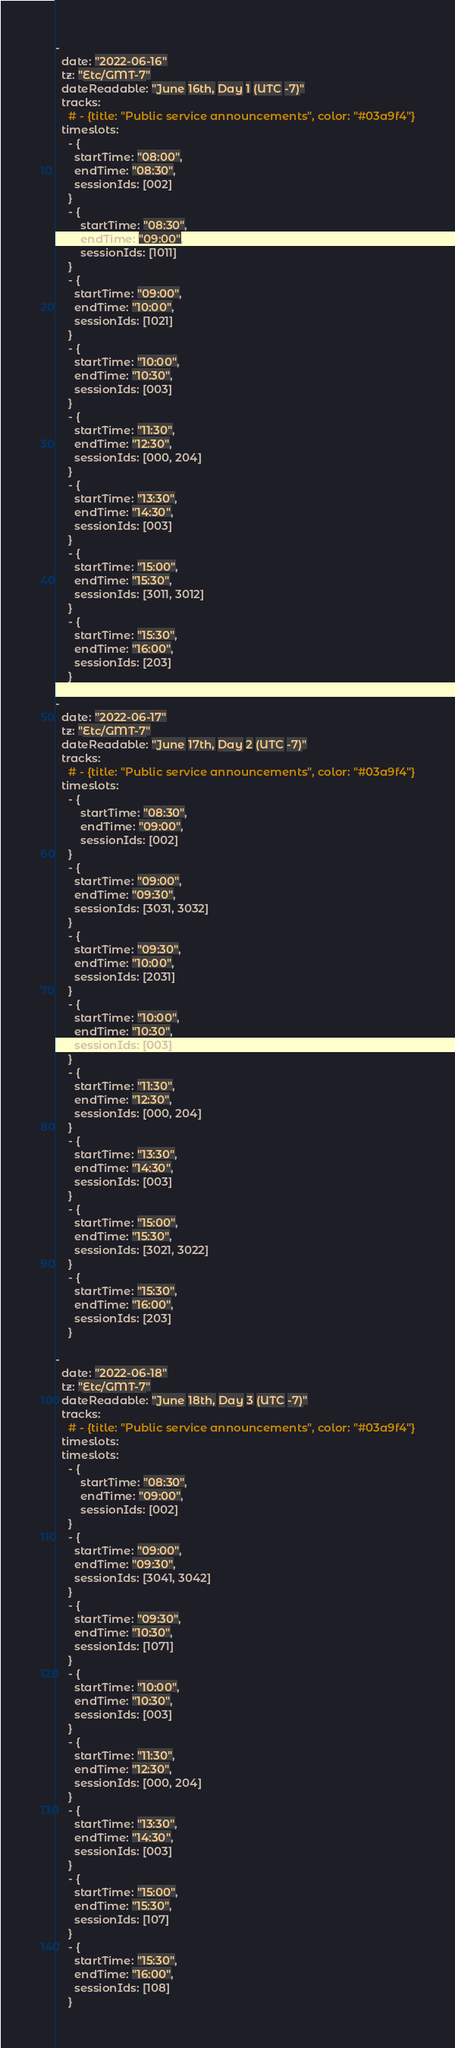<code> <loc_0><loc_0><loc_500><loc_500><_YAML_>-
  date: "2022-06-16"
  tz: "Etc/GMT-7"
  dateReadable: "June 16th, Day 1 (UTC -7)"
  tracks:
    # - {title: "Public service announcements", color: "#03a9f4"}
  timeslots:
    - {
      startTime: "08:00",
      endTime: "08:30",
      sessionIds: [002]
    }
    - {
        startTime: "08:30",
        endTime: "09:00",
        sessionIds: [1011]
    }
    - {
      startTime: "09:00",
      endTime: "10:00",
      sessionIds: [1021]
    }
    - {
      startTime: "10:00",
      endTime: "10:30",
      sessionIds: [003]
    }
    - {
      startTime: "11:30",
      endTime: "12:30",
      sessionIds: [000, 204]
    }
    - {
      startTime: "13:30",
      endTime: "14:30",
      sessionIds: [003]
    }
    - {
      startTime: "15:00",
      endTime: "15:30",
      sessionIds: [3011, 3012]
    }
    - {
      startTime: "15:30",
      endTime: "16:00",
      sessionIds: [203]
    }

-
  date: "2022-06-17"
  tz: "Etc/GMT-7"
  dateReadable: "June 17th, Day 2 (UTC -7)"
  tracks:
    # - {title: "Public service announcements", color: "#03a9f4"}
  timeslots:
    - {
        startTime: "08:30",
        endTime: "09:00",
        sessionIds: [002]
    }
    - {
      startTime: "09:00",
      endTime: "09:30",
      sessionIds: [3031, 3032]
    }
    - {
      startTime: "09:30",
      endTime: "10:00",
      sessionIds: [2031]
    }
    - {
      startTime: "10:00",
      endTime: "10:30",
      sessionIds: [003]
    }
    - {
      startTime: "11:30",
      endTime: "12:30",
      sessionIds: [000, 204]
    }
    - {
      startTime: "13:30",
      endTime: "14:30",
      sessionIds: [003]
    }
    - {
      startTime: "15:00",
      endTime: "15:30",
      sessionIds: [3021, 3022]
    }
    - {
      startTime: "15:30",
      endTime: "16:00",
      sessionIds: [203]
    }

-
  date: "2022-06-18"
  tz: "Etc/GMT-7"
  dateReadable: "June 18th, Day 3 (UTC -7)"
  tracks:
    # - {title: "Public service announcements", color: "#03a9f4"}
  timeslots:
  timeslots:
    - {
        startTime: "08:30",
        endTime: "09:00",
        sessionIds: [002]
    }
    - {
      startTime: "09:00",
      endTime: "09:30",
      sessionIds: [3041, 3042]
    }
    - {
      startTime: "09:30",
      endTime: "10:30",
      sessionIds: [1071]
    }
    - {
      startTime: "10:00",
      endTime: "10:30",
      sessionIds: [003]
    }
    - {
      startTime: "11:30",
      endTime: "12:30",
      sessionIds: [000, 204]
    }
    - {
      startTime: "13:30",
      endTime: "14:30",
      sessionIds: [003]
    }
    - {
      startTime: "15:00",
      endTime: "15:30",
      sessionIds: [107]
    }
    - {
      startTime: "15:30",
      endTime: "16:00",
      sessionIds: [108]
    }
</code> 